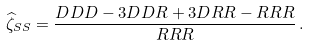Convert formula to latex. <formula><loc_0><loc_0><loc_500><loc_500>\widehat { \zeta } _ { S S } = \frac { D D D - 3 D D R + 3 D R R - R R R } { R R R } \, .</formula> 